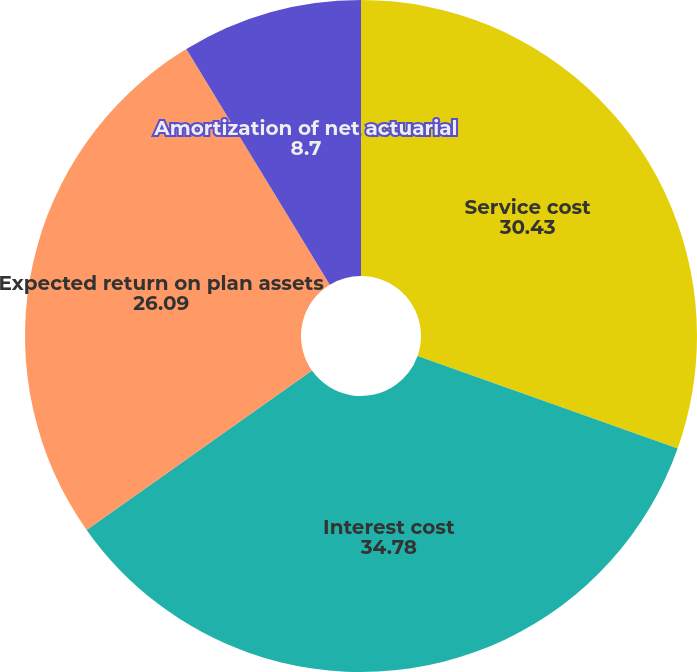Convert chart to OTSL. <chart><loc_0><loc_0><loc_500><loc_500><pie_chart><fcel>Service cost<fcel>Interest cost<fcel>Expected return on plan assets<fcel>Amortization of net actuarial<nl><fcel>30.43%<fcel>34.78%<fcel>26.09%<fcel>8.7%<nl></chart> 